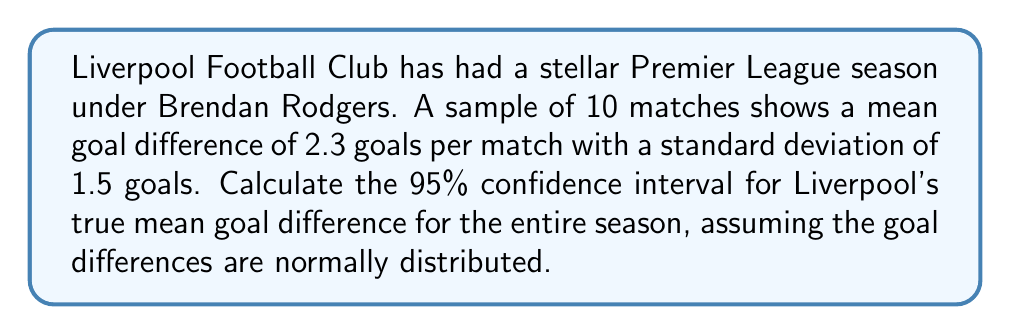Could you help me with this problem? To calculate the 95% confidence interval, we'll follow these steps:

1) We're given:
   - Sample size, $n = 10$
   - Sample mean, $\bar{x} = 2.3$
   - Sample standard deviation, $s = 1.5$
   - Confidence level = 95%

2) For a 95% confidence interval with 9 degrees of freedom (n-1), the t-value is 2.262 (from t-distribution table).

3) The formula for the confidence interval is:

   $$\bar{x} \pm t_{\alpha/2} \cdot \frac{s}{\sqrt{n}}$$

4) Substituting our values:

   $$2.3 \pm 2.262 \cdot \frac{1.5}{\sqrt{10}}$$

5) Simplify:
   $$2.3 \pm 2.262 \cdot 0.4743$$
   $$2.3 \pm 1.0731$$

6) Calculate the interval:
   Lower bound: $2.3 - 1.0731 = 1.2269$
   Upper bound: $2.3 + 1.0731 = 3.3731$

Therefore, we are 95% confident that Liverpool's true mean goal difference for the entire season falls between 1.2269 and 3.3731 goals per match.
Answer: (1.2269, 3.3731) 